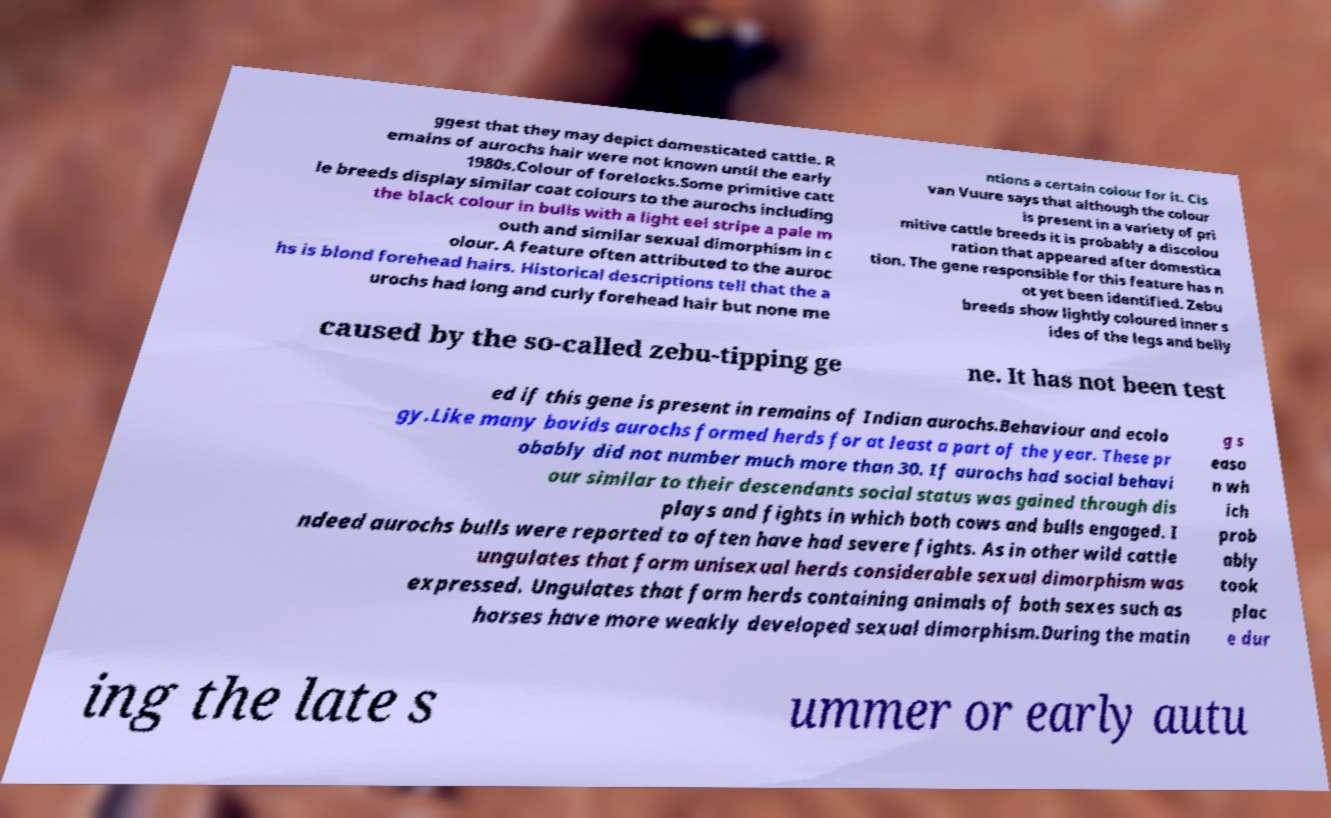Could you assist in decoding the text presented in this image and type it out clearly? ggest that they may depict domesticated cattle. R emains of aurochs hair were not known until the early 1980s.Colour of forelocks.Some primitive catt le breeds display similar coat colours to the aurochs including the black colour in bulls with a light eel stripe a pale m outh and similar sexual dimorphism in c olour. A feature often attributed to the auroc hs is blond forehead hairs. Historical descriptions tell that the a urochs had long and curly forehead hair but none me ntions a certain colour for it. Cis van Vuure says that although the colour is present in a variety of pri mitive cattle breeds it is probably a discolou ration that appeared after domestica tion. The gene responsible for this feature has n ot yet been identified. Zebu breeds show lightly coloured inner s ides of the legs and belly caused by the so-called zebu-tipping ge ne. It has not been test ed if this gene is present in remains of Indian aurochs.Behaviour and ecolo gy.Like many bovids aurochs formed herds for at least a part of the year. These pr obably did not number much more than 30. If aurochs had social behavi our similar to their descendants social status was gained through dis plays and fights in which both cows and bulls engaged. I ndeed aurochs bulls were reported to often have had severe fights. As in other wild cattle ungulates that form unisexual herds considerable sexual dimorphism was expressed. Ungulates that form herds containing animals of both sexes such as horses have more weakly developed sexual dimorphism.During the matin g s easo n wh ich prob ably took plac e dur ing the late s ummer or early autu 